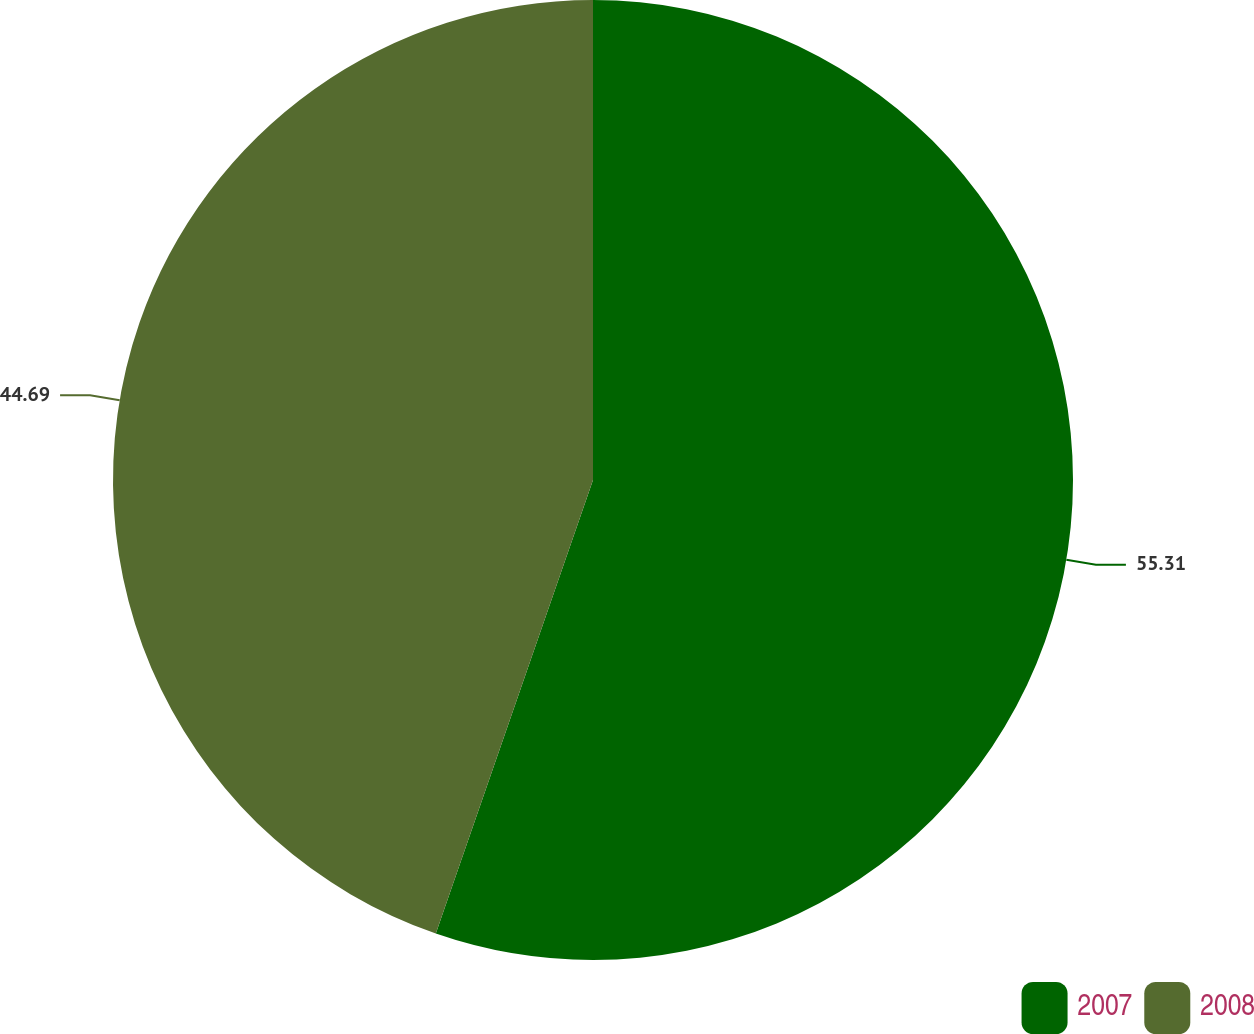Convert chart. <chart><loc_0><loc_0><loc_500><loc_500><pie_chart><fcel>2007<fcel>2008<nl><fcel>55.31%<fcel>44.69%<nl></chart> 